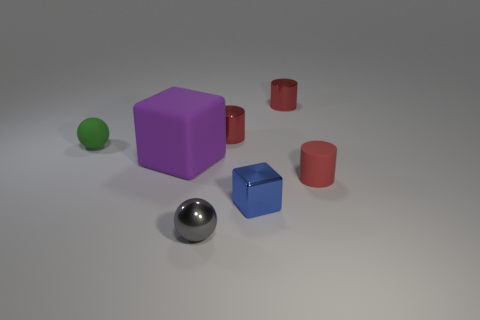There is a tiny rubber thing behind the small red thing that is in front of the small ball behind the red matte object; what shape is it?
Keep it short and to the point. Sphere. What number of big red shiny cylinders are there?
Make the answer very short. 0. There is a ball that is in front of the tiny matte thing that is to the right of the purple object; what is its material?
Provide a succinct answer. Metal. What color is the tiny thing behind the shiny cylinder left of the small metallic object that is right of the blue thing?
Your answer should be very brief. Red. Is the color of the large matte cube the same as the small rubber cylinder?
Ensure brevity in your answer.  No. How many metallic cylinders have the same size as the red rubber cylinder?
Provide a short and direct response. 2. Are there more red rubber objects that are in front of the matte block than gray spheres that are left of the green object?
Offer a terse response. Yes. What is the color of the block to the right of the gray metallic sphere that is in front of the rubber sphere?
Offer a terse response. Blue. Does the tiny blue thing have the same material as the tiny gray thing?
Make the answer very short. Yes. Is there another thing that has the same shape as the purple matte object?
Your response must be concise. Yes. 